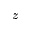<formula> <loc_0><loc_0><loc_500><loc_500>z</formula> 